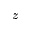<formula> <loc_0><loc_0><loc_500><loc_500>z</formula> 